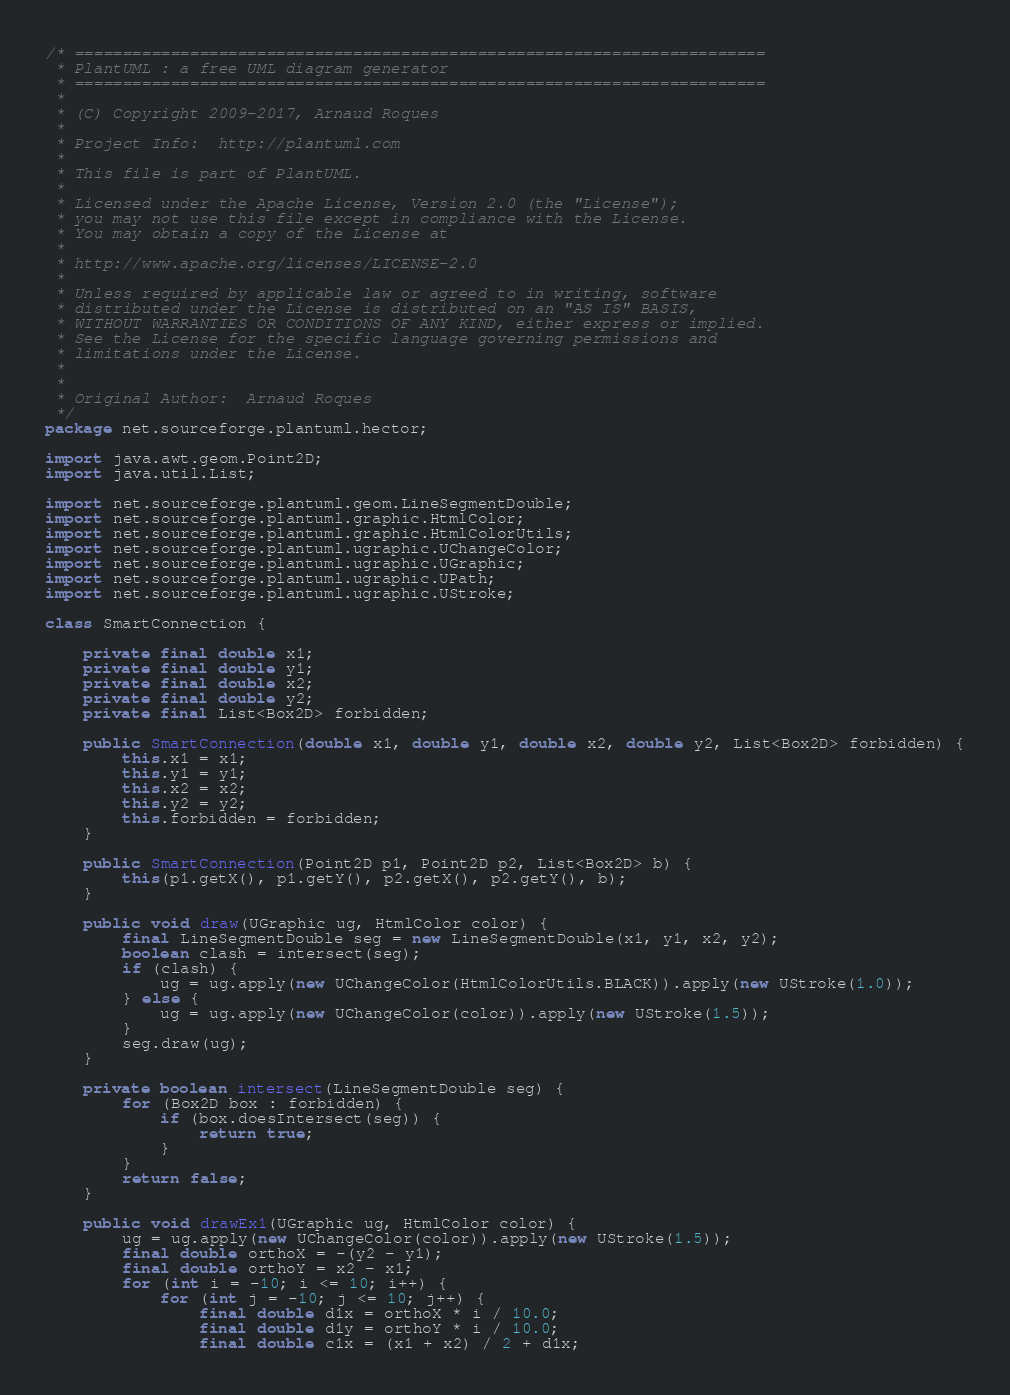<code> <loc_0><loc_0><loc_500><loc_500><_Java_>/* ========================================================================
 * PlantUML : a free UML diagram generator
 * ========================================================================
 *
 * (C) Copyright 2009-2017, Arnaud Roques
 *
 * Project Info:  http://plantuml.com
 * 
 * This file is part of PlantUML.
 *
 * Licensed under the Apache License, Version 2.0 (the "License");
 * you may not use this file except in compliance with the License.
 * You may obtain a copy of the License at
 * 
 * http://www.apache.org/licenses/LICENSE-2.0
 * 
 * Unless required by applicable law or agreed to in writing, software
 * distributed under the License is distributed on an "AS IS" BASIS,
 * WITHOUT WARRANTIES OR CONDITIONS OF ANY KIND, either express or implied.
 * See the License for the specific language governing permissions and
 * limitations under the License.
 *
 *
 * Original Author:  Arnaud Roques
 */
package net.sourceforge.plantuml.hector;

import java.awt.geom.Point2D;
import java.util.List;

import net.sourceforge.plantuml.geom.LineSegmentDouble;
import net.sourceforge.plantuml.graphic.HtmlColor;
import net.sourceforge.plantuml.graphic.HtmlColorUtils;
import net.sourceforge.plantuml.ugraphic.UChangeColor;
import net.sourceforge.plantuml.ugraphic.UGraphic;
import net.sourceforge.plantuml.ugraphic.UPath;
import net.sourceforge.plantuml.ugraphic.UStroke;

class SmartConnection {

	private final double x1;
	private final double y1;
	private final double x2;
	private final double y2;
	private final List<Box2D> forbidden;

	public SmartConnection(double x1, double y1, double x2, double y2, List<Box2D> forbidden) {
		this.x1 = x1;
		this.y1 = y1;
		this.x2 = x2;
		this.y2 = y2;
		this.forbidden = forbidden;
	}

	public SmartConnection(Point2D p1, Point2D p2, List<Box2D> b) {
		this(p1.getX(), p1.getY(), p2.getX(), p2.getY(), b);
	}

	public void draw(UGraphic ug, HtmlColor color) {
		final LineSegmentDouble seg = new LineSegmentDouble(x1, y1, x2, y2);
		boolean clash = intersect(seg);
		if (clash) {
			ug = ug.apply(new UChangeColor(HtmlColorUtils.BLACK)).apply(new UStroke(1.0));
		} else {
			ug = ug.apply(new UChangeColor(color)).apply(new UStroke(1.5));
		}
		seg.draw(ug);
	}

	private boolean intersect(LineSegmentDouble seg) {
		for (Box2D box : forbidden) {
			if (box.doesIntersect(seg)) {
				return true;
			}
		}
		return false;
	}

	public void drawEx1(UGraphic ug, HtmlColor color) {
		ug = ug.apply(new UChangeColor(color)).apply(new UStroke(1.5));
		final double orthoX = -(y2 - y1);
		final double orthoY = x2 - x1;
		for (int i = -10; i <= 10; i++) {
			for (int j = -10; j <= 10; j++) {
				final double d1x = orthoX * i / 10.0;
				final double d1y = orthoY * i / 10.0;
				final double c1x = (x1 + x2) / 2 + d1x;</code> 